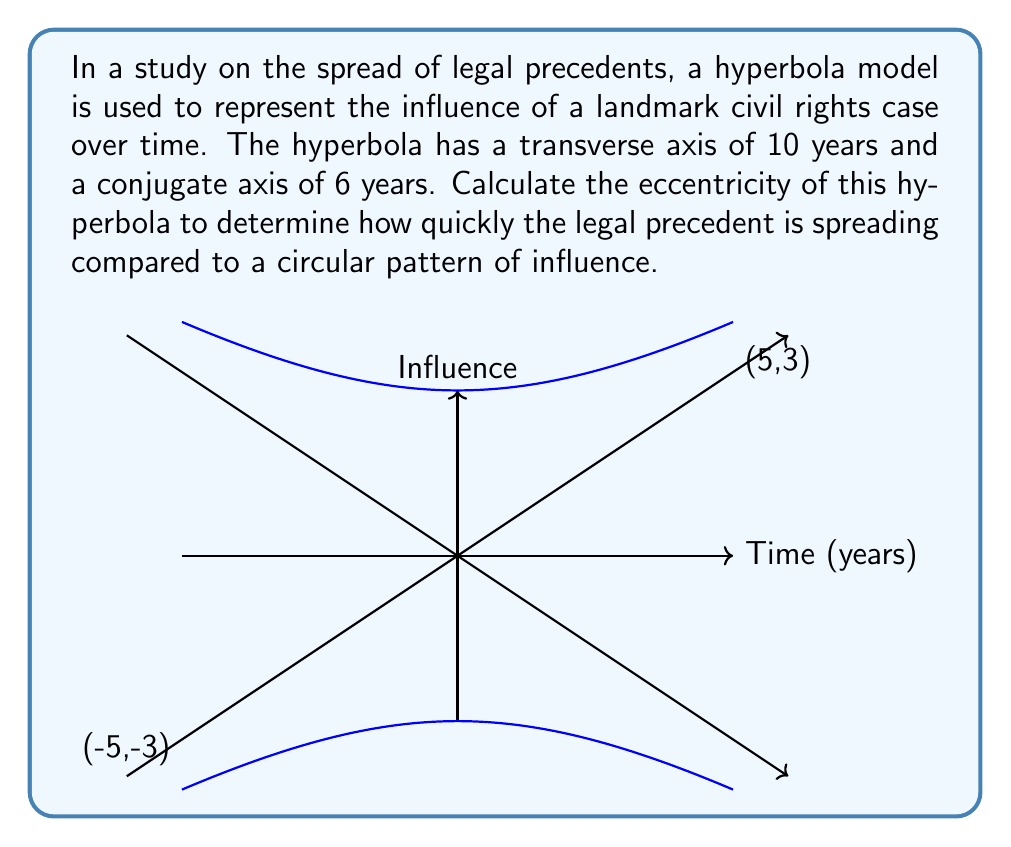Can you answer this question? To calculate the eccentricity of a hyperbola, we need to follow these steps:

1) The eccentricity (e) of a hyperbola is given by the formula:

   $$e = \sqrt{1 + \frac{b^2}{a^2}}$$

   where $a$ is half the length of the transverse axis and $b$ is half the length of the conjugate axis.

2) From the given information:
   Transverse axis = 10 years, so $a = 5$ years
   Conjugate axis = 6 years, so $b = 3$ years

3) Substituting these values into the formula:

   $$e = \sqrt{1 + \frac{3^2}{5^2}}$$

4) Simplify:
   $$e = \sqrt{1 + \frac{9}{25}}$$
   $$e = \sqrt{\frac{25}{25} + \frac{9}{25}}$$
   $$e = \sqrt{\frac{34}{25}}$$

5) Simplify the fraction under the square root:
   $$e = \frac{\sqrt{34}}{5}$$

This eccentricity value (greater than 1) indicates that the legal precedent is spreading more quickly than it would in a circular pattern of influence. The higher the eccentricity, the more elongated the hyperbola, suggesting a faster rate of spread along the transverse axis (time, in this case) compared to the conjugate axis (influence).
Answer: $\frac{\sqrt{34}}{5}$ 